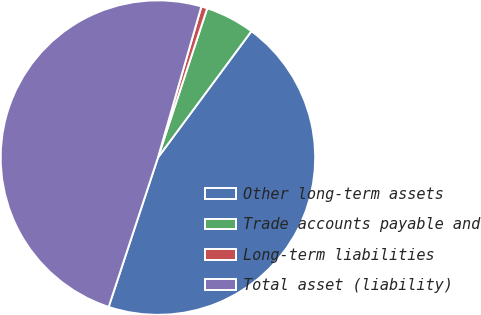Convert chart. <chart><loc_0><loc_0><loc_500><loc_500><pie_chart><fcel>Other long-term assets<fcel>Trade accounts payable and<fcel>Long-term liabilities<fcel>Total asset (liability)<nl><fcel>44.94%<fcel>5.06%<fcel>0.62%<fcel>49.38%<nl></chart> 